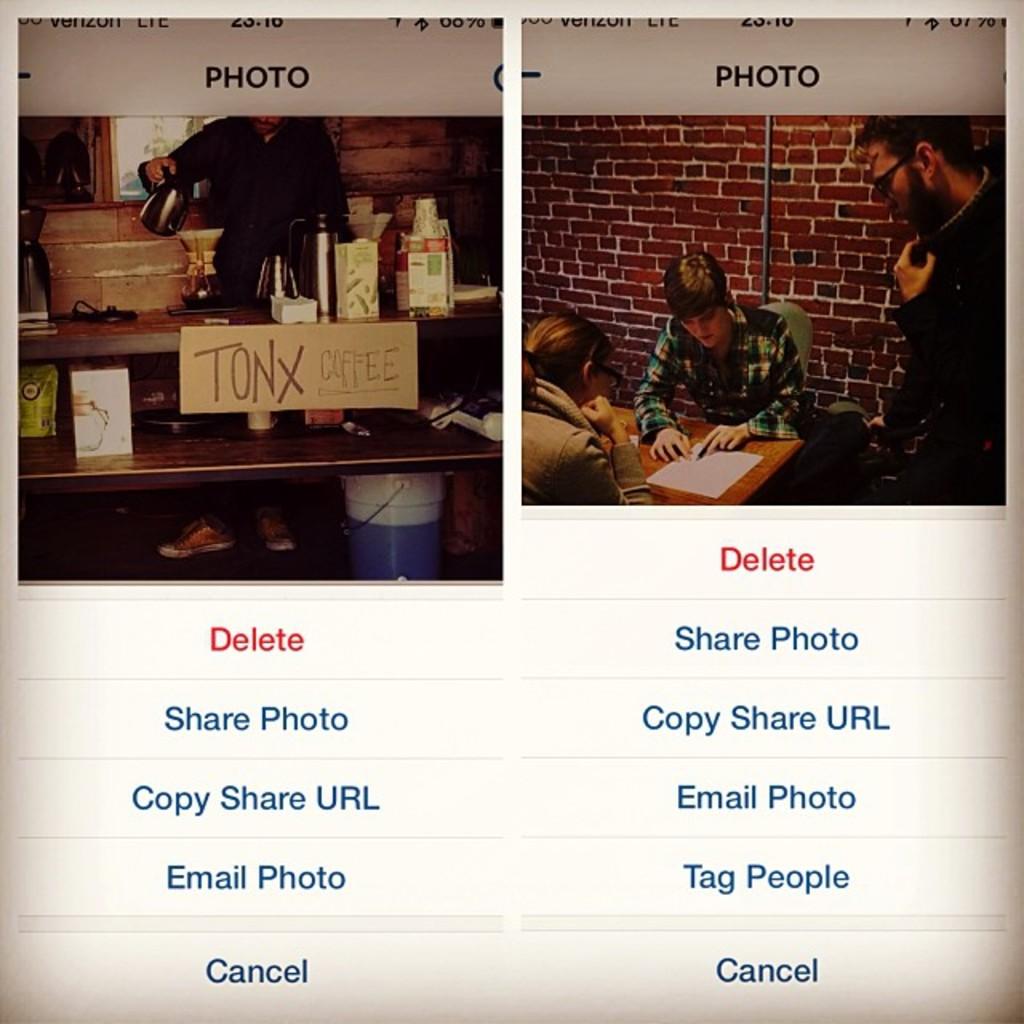What kind of coffee is being served?
Provide a succinct answer. Tonx. What will happen if we press the button with red text?
Give a very brief answer. Delete. 